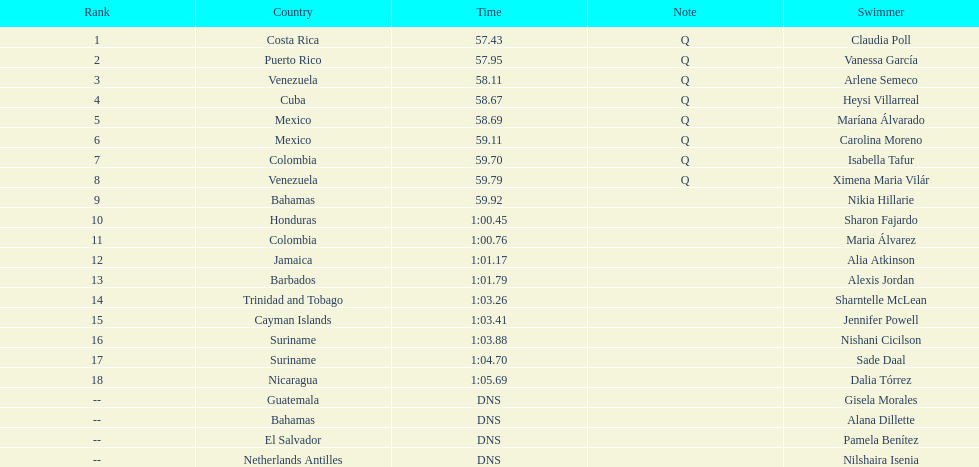What was claudia roll's time? 57.43. Can you give me this table as a dict? {'header': ['Rank', 'Country', 'Time', 'Note', 'Swimmer'], 'rows': [['1', 'Costa Rica', '57.43', 'Q', 'Claudia Poll'], ['2', 'Puerto Rico', '57.95', 'Q', 'Vanessa García'], ['3', 'Venezuela', '58.11', 'Q', 'Arlene Semeco'], ['4', 'Cuba', '58.67', 'Q', 'Heysi Villarreal'], ['5', 'Mexico', '58.69', 'Q', 'Maríana Álvarado'], ['6', 'Mexico', '59.11', 'Q', 'Carolina Moreno'], ['7', 'Colombia', '59.70', 'Q', 'Isabella Tafur'], ['8', 'Venezuela', '59.79', 'Q', 'Ximena Maria Vilár'], ['9', 'Bahamas', '59.92', '', 'Nikia Hillarie'], ['10', 'Honduras', '1:00.45', '', 'Sharon Fajardo'], ['11', 'Colombia', '1:00.76', '', 'Maria Álvarez'], ['12', 'Jamaica', '1:01.17', '', 'Alia Atkinson'], ['13', 'Barbados', '1:01.79', '', 'Alexis Jordan'], ['14', 'Trinidad and Tobago', '1:03.26', '', 'Sharntelle McLean'], ['15', 'Cayman Islands', '1:03.41', '', 'Jennifer Powell'], ['16', 'Suriname', '1:03.88', '', 'Nishani Cicilson'], ['17', 'Suriname', '1:04.70', '', 'Sade Daal'], ['18', 'Nicaragua', '1:05.69', '', 'Dalia Tórrez'], ['--', 'Guatemala', 'DNS', '', 'Gisela Morales'], ['--', 'Bahamas', 'DNS', '', 'Alana Dillette'], ['--', 'El Salvador', 'DNS', '', 'Pamela Benítez'], ['--', 'Netherlands Antilles', 'DNS', '', 'Nilshaira Isenia']]} 